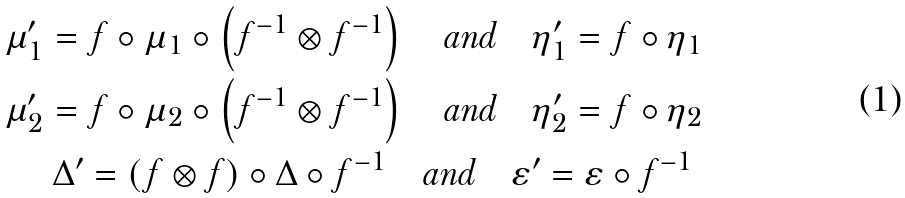Convert formula to latex. <formula><loc_0><loc_0><loc_500><loc_500>\mu _ { 1 } ^ { \prime } = f \circ \mu _ { 1 } \circ \left ( f ^ { - 1 } \otimes f ^ { - 1 } \right ) \quad \text {and} \quad \eta _ { 1 } ^ { \prime } = f \circ \eta _ { 1 } \\ \mu _ { 2 } ^ { \prime } = f \circ \mu _ { 2 } \circ \left ( f ^ { - 1 } \otimes f ^ { - 1 } \right ) \quad \text {and} \quad \eta _ { 2 } ^ { \prime } = f \circ \eta _ { 2 } \\ \Delta ^ { \prime } = ( f \otimes f ) \circ \Delta \circ f ^ { - 1 } \quad \text {and} \quad \varepsilon ^ { \prime } = \varepsilon \circ f ^ { - 1 } \</formula> 